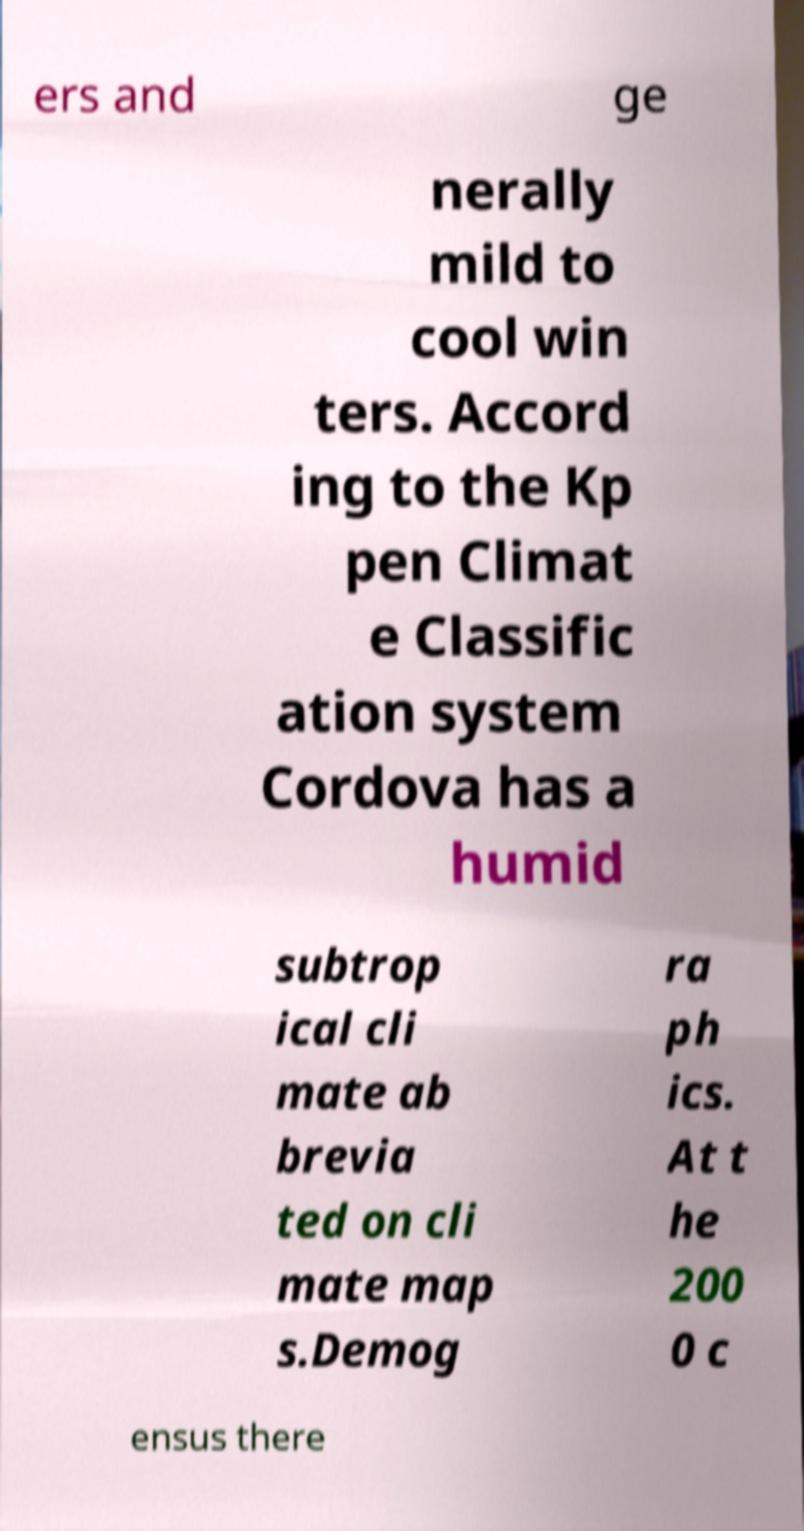Could you extract and type out the text from this image? ers and ge nerally mild to cool win ters. Accord ing to the Kp pen Climat e Classific ation system Cordova has a humid subtrop ical cli mate ab brevia ted on cli mate map s.Demog ra ph ics. At t he 200 0 c ensus there 